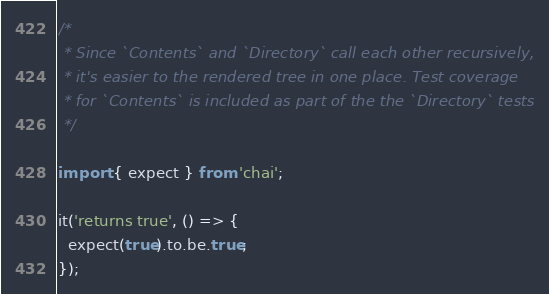<code> <loc_0><loc_0><loc_500><loc_500><_JavaScript_>/*
 * Since `Contents` and `Directory` call each other recursively,
 * it's easier to the rendered tree in one place. Test coverage
 * for `Contents` is included as part of the the `Directory` tests
 */

import { expect } from 'chai';

it('returns true', () => {
  expect(true).to.be.true;
});
</code> 